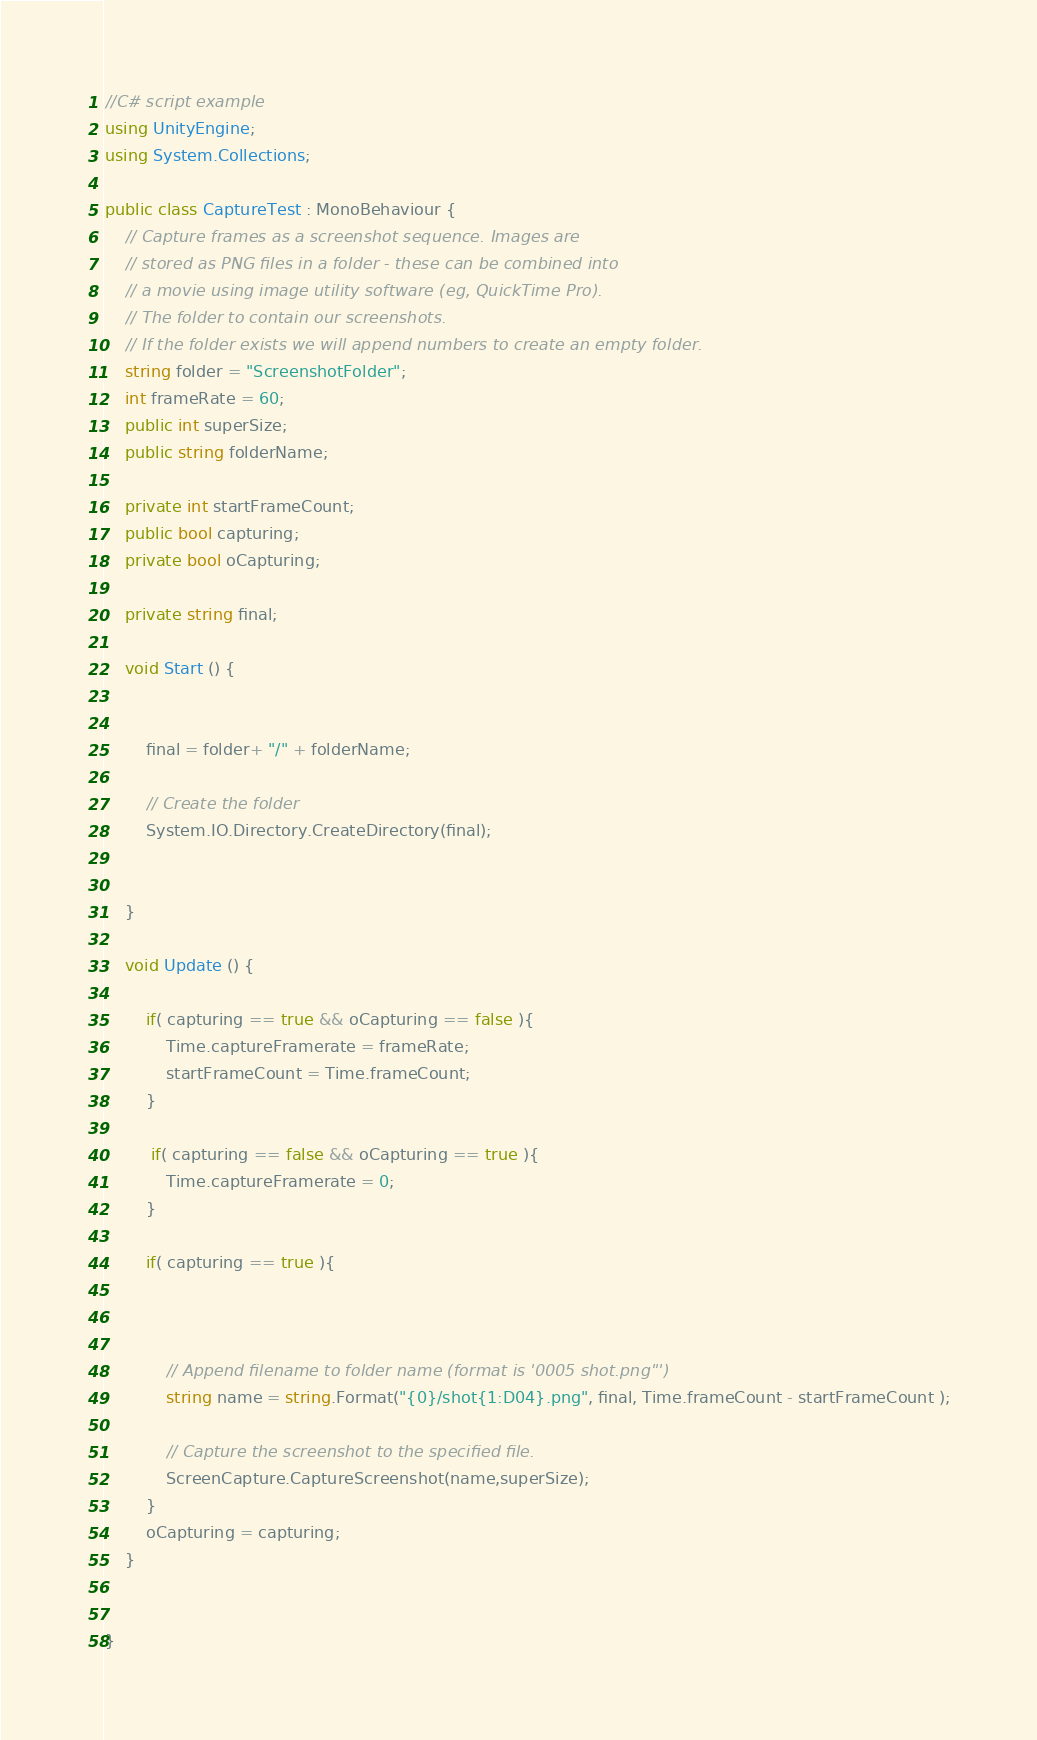<code> <loc_0><loc_0><loc_500><loc_500><_C#_>//C# script example
using UnityEngine;
using System.Collections;

public class CaptureTest : MonoBehaviour {
    // Capture frames as a screenshot sequence. Images are
    // stored as PNG files in a folder - these can be combined into
    // a movie using image utility software (eg, QuickTime Pro).
    // The folder to contain our screenshots.
    // If the folder exists we will append numbers to create an empty folder.
    string folder = "ScreenshotFolder";
    int frameRate = 60;
    public int superSize;
    public string folderName;

    private int startFrameCount;
    public bool capturing;
    private bool oCapturing;

    private string final;

    void Start () {


        final = folder+ "/" + folderName;

        // Create the folder
        System.IO.Directory.CreateDirectory(final);


    }

    void Update () {

        if( capturing == true && oCapturing == false ){
            Time.captureFramerate = frameRate;
            startFrameCount = Time.frameCount;
        }

         if( capturing == false && oCapturing == true ){
            Time.captureFramerate = 0;
        }

        if( capturing == true ){



            // Append filename to folder name (format is '0005 shot.png"')
            string name = string.Format("{0}/shot{1:D04}.png", final, Time.frameCount - startFrameCount );

            // Capture the screenshot to the specified file.
            ScreenCapture.CaptureScreenshot(name,superSize);
        }
        oCapturing = capturing;
    }


}
</code> 